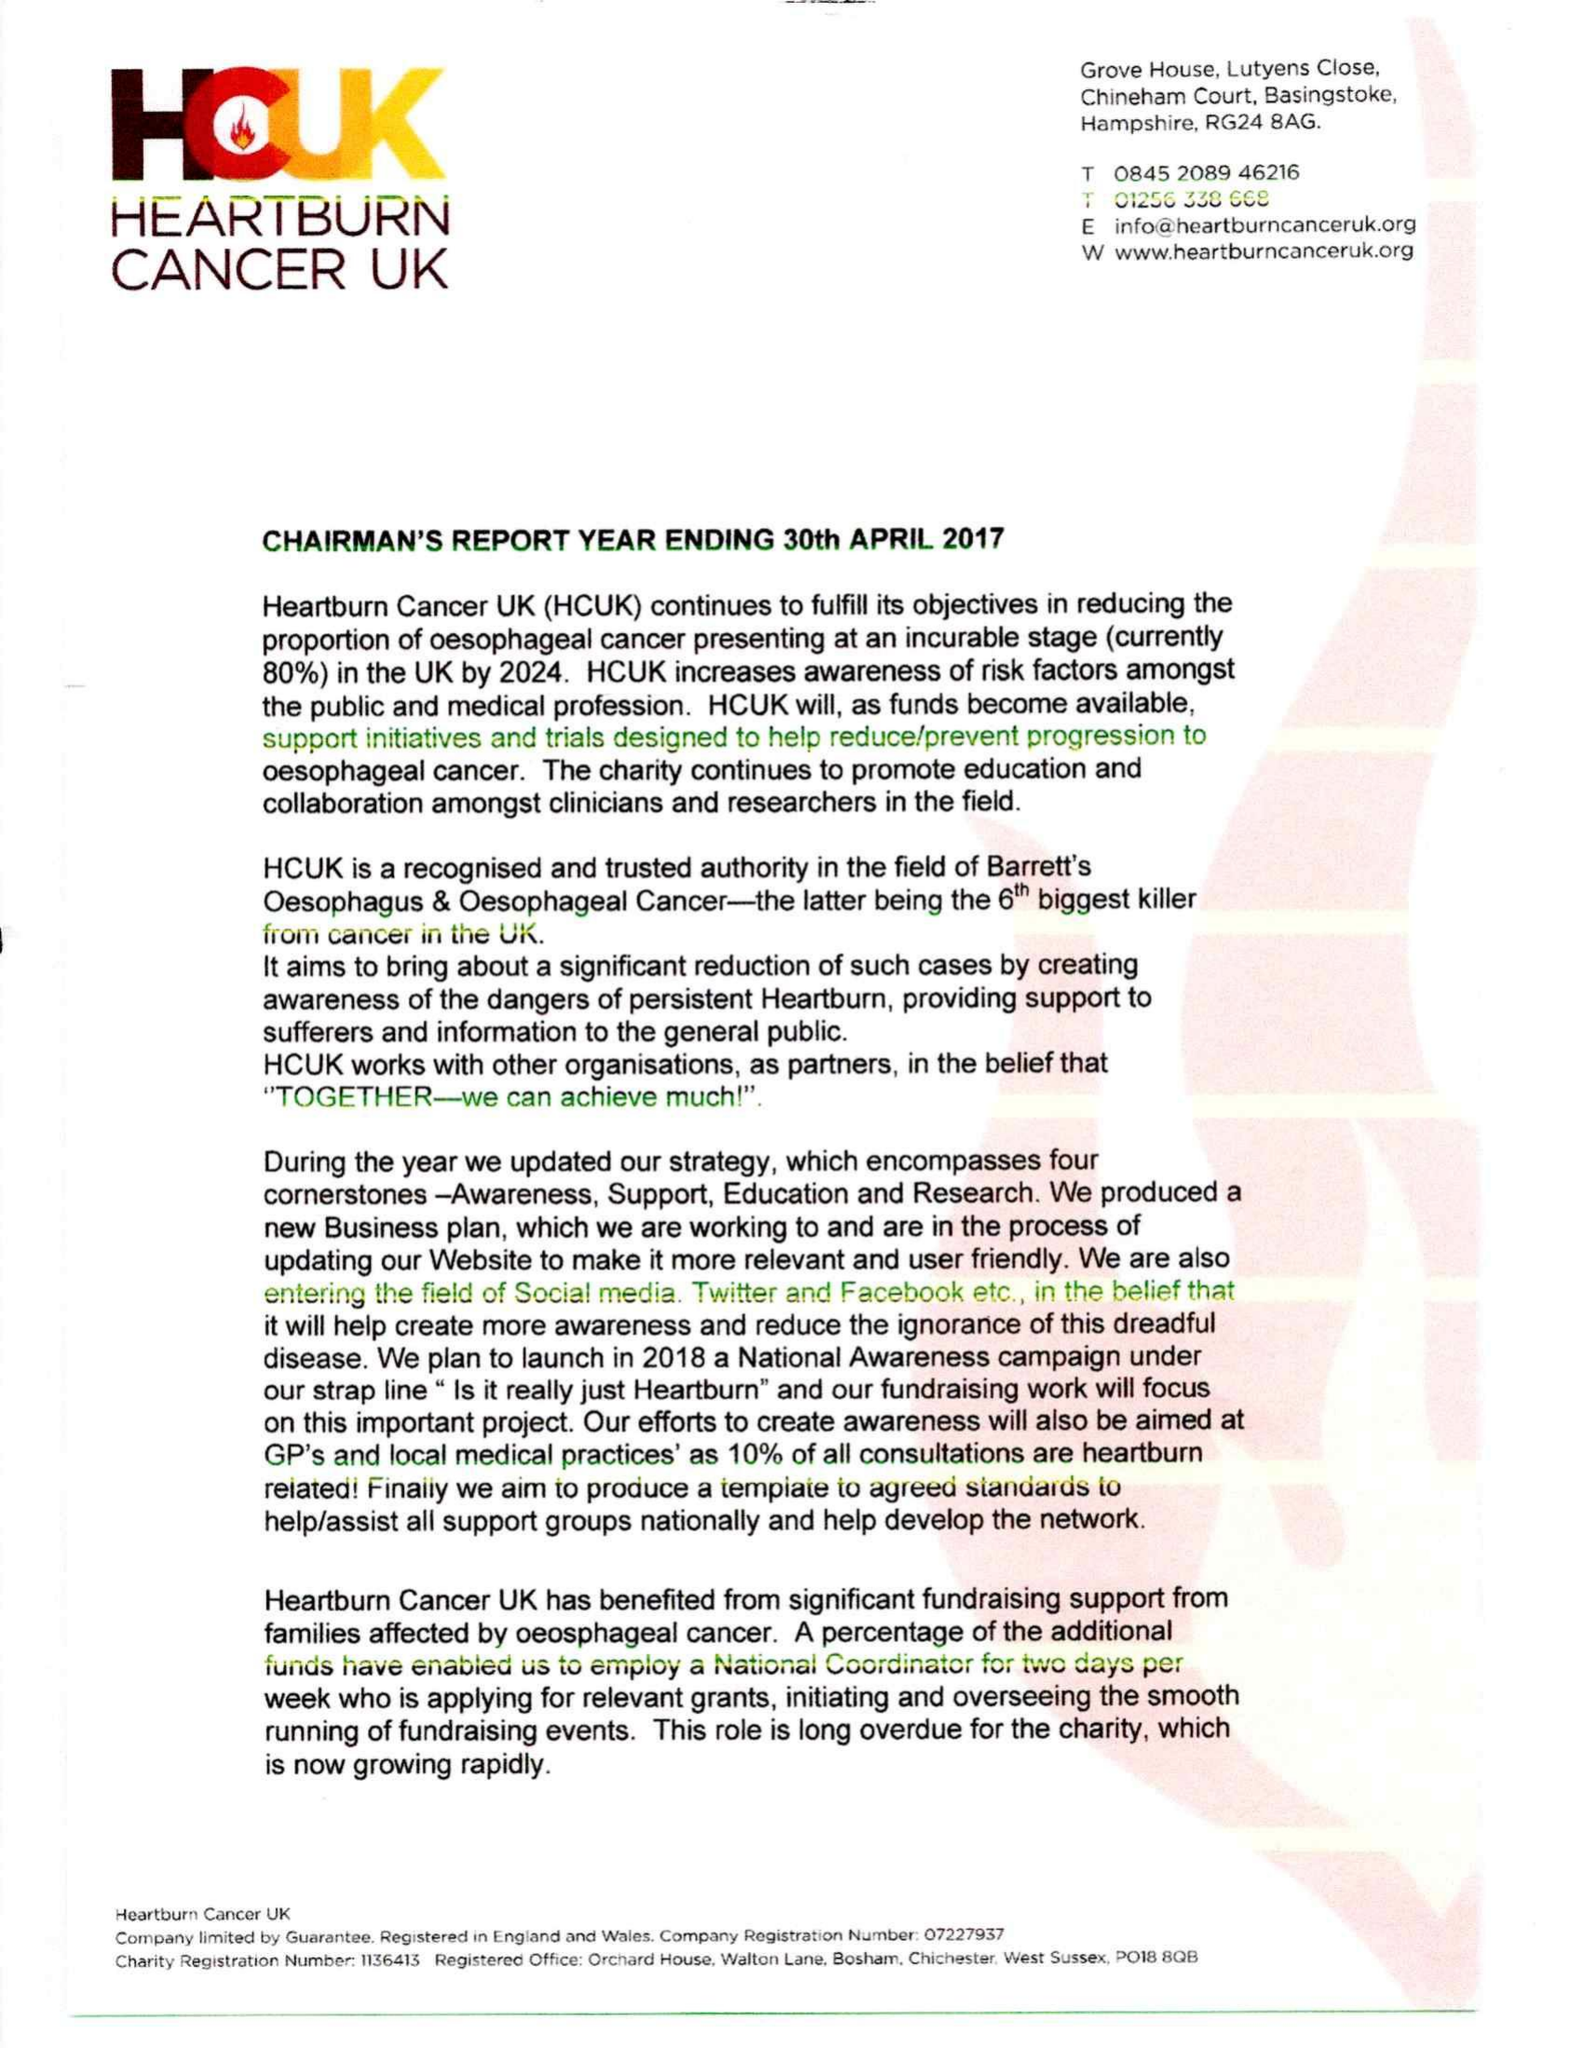What is the value for the report_date?
Answer the question using a single word or phrase. 2017-04-30 